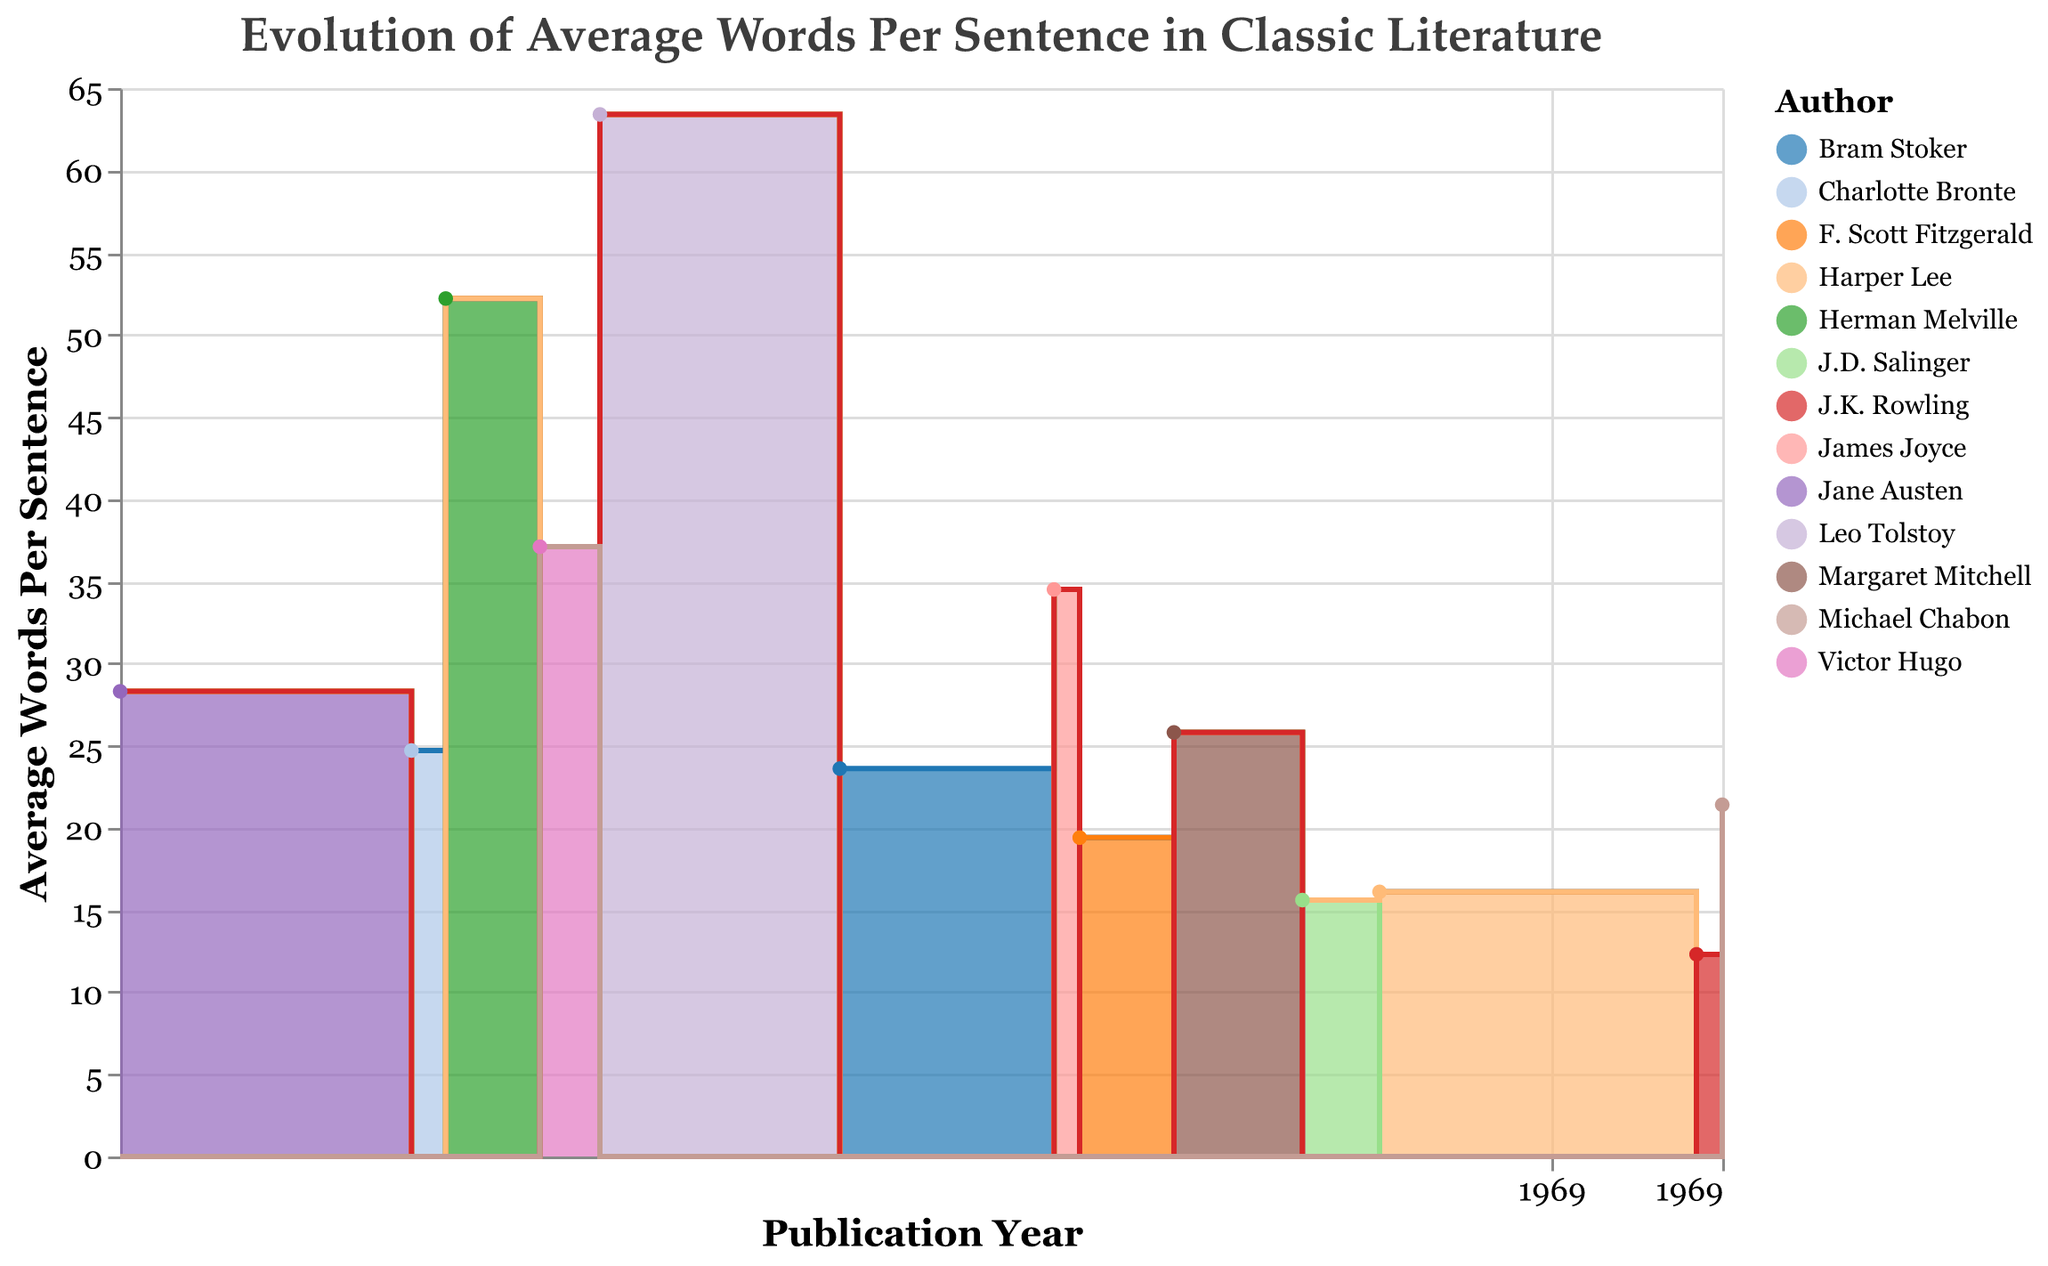What is the title of the figure? The title can be found at the top of the figure, which describes what the chart is about.
Answer: Evolution of Average Words Per Sentence in Classic Literature What is the range of years displayed on the x-axis? The x-axis shows publication years, ranging from the earliest to the latest year in the dataset. You can see the earliest point is 1813 and the latest is 2000.
Answer: 1813 to 2000 Which book has the highest average words per sentence? By looking at the y-axis values and identifying the peak, the highest average words per sentence can be found. The data point for "War and Peace" by Leo Tolstoy in 1869 reaches the highest point.
Answer: War and Peace Which author has an average words per sentence near 34? Identify the data point near 34 on the y-axis and find the corresponding tooltip information, which includes the author. James Joyce's "Ulysses" in 1922 hovers around this value.
Answer: James Joyce How does the average words per sentence in "To Kill a Mockingbird" compare to "The Catcher in the Rye"? Compare the y-axis values for both books. "To Kill a Mockingbird" has an average of 16.1 words per sentence, which is slightly higher than "The Catcher in the Rye" with 15.6 words.
Answer: "To Kill a Mockingbird" is higher What is the median average words per sentence in the given dataset? List all average words per sentence values, order them, and find the middle value. The ordered values are: 12.3, 15.6, 16.1, 19.4, 21.4, 23.6, 24.7, 25.8, 28.3, 34.5, 37.1, 52.2, 63.4. The median is the middle value, which is 25.8.
Answer: 25.8 Identify the longest period without a significant increase or decrease in average words per sentence. Look at the steps in the step area chart from left to right, and find the longest interval where the y-values remain relatively constant. Notable stability is seen from 1960 ("To Kill a Mockingbird") to 1997 ("Harry Potter and the Philosopher's Stone").
Answer: 1960 to 1997 Which two adjacent data points have the greatest difference in average words per sentence? Calculate the differences between each pair of adjacent data points and identify the greatest. The largest difference is between "War and Peace" (1869, 63.4) and "Dracula" (1897, 23.6), which is a difference of 39.8.
Answer: Between 1869 and 1897 What trend can be observed in the average words per sentence over time? By observing the general shape and direction of the areas in the step area chart, note if there is a general increase, decrease, or other pattern. There is a noticeable downward trend indicating that average words per sentence have generally decreased over time.
Answer: Decreasing over time 